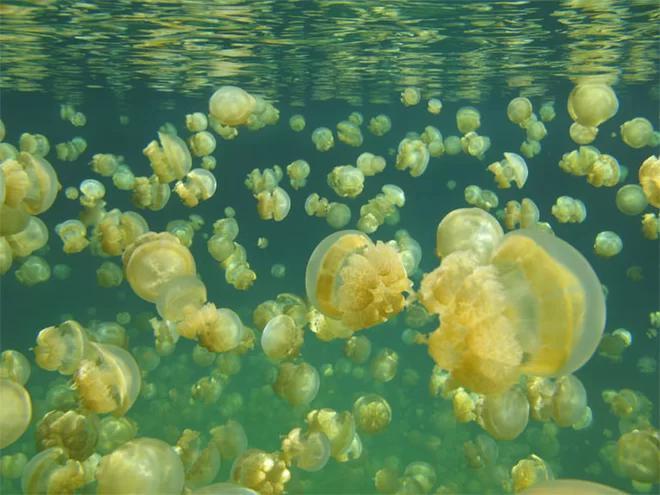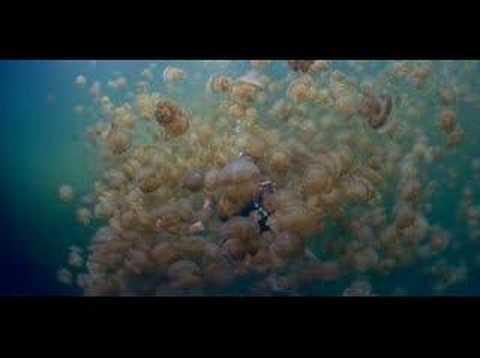The first image is the image on the left, the second image is the image on the right. For the images displayed, is the sentence "The rippled surface of the water is visible in one of the images." factually correct? Answer yes or no. Yes. 